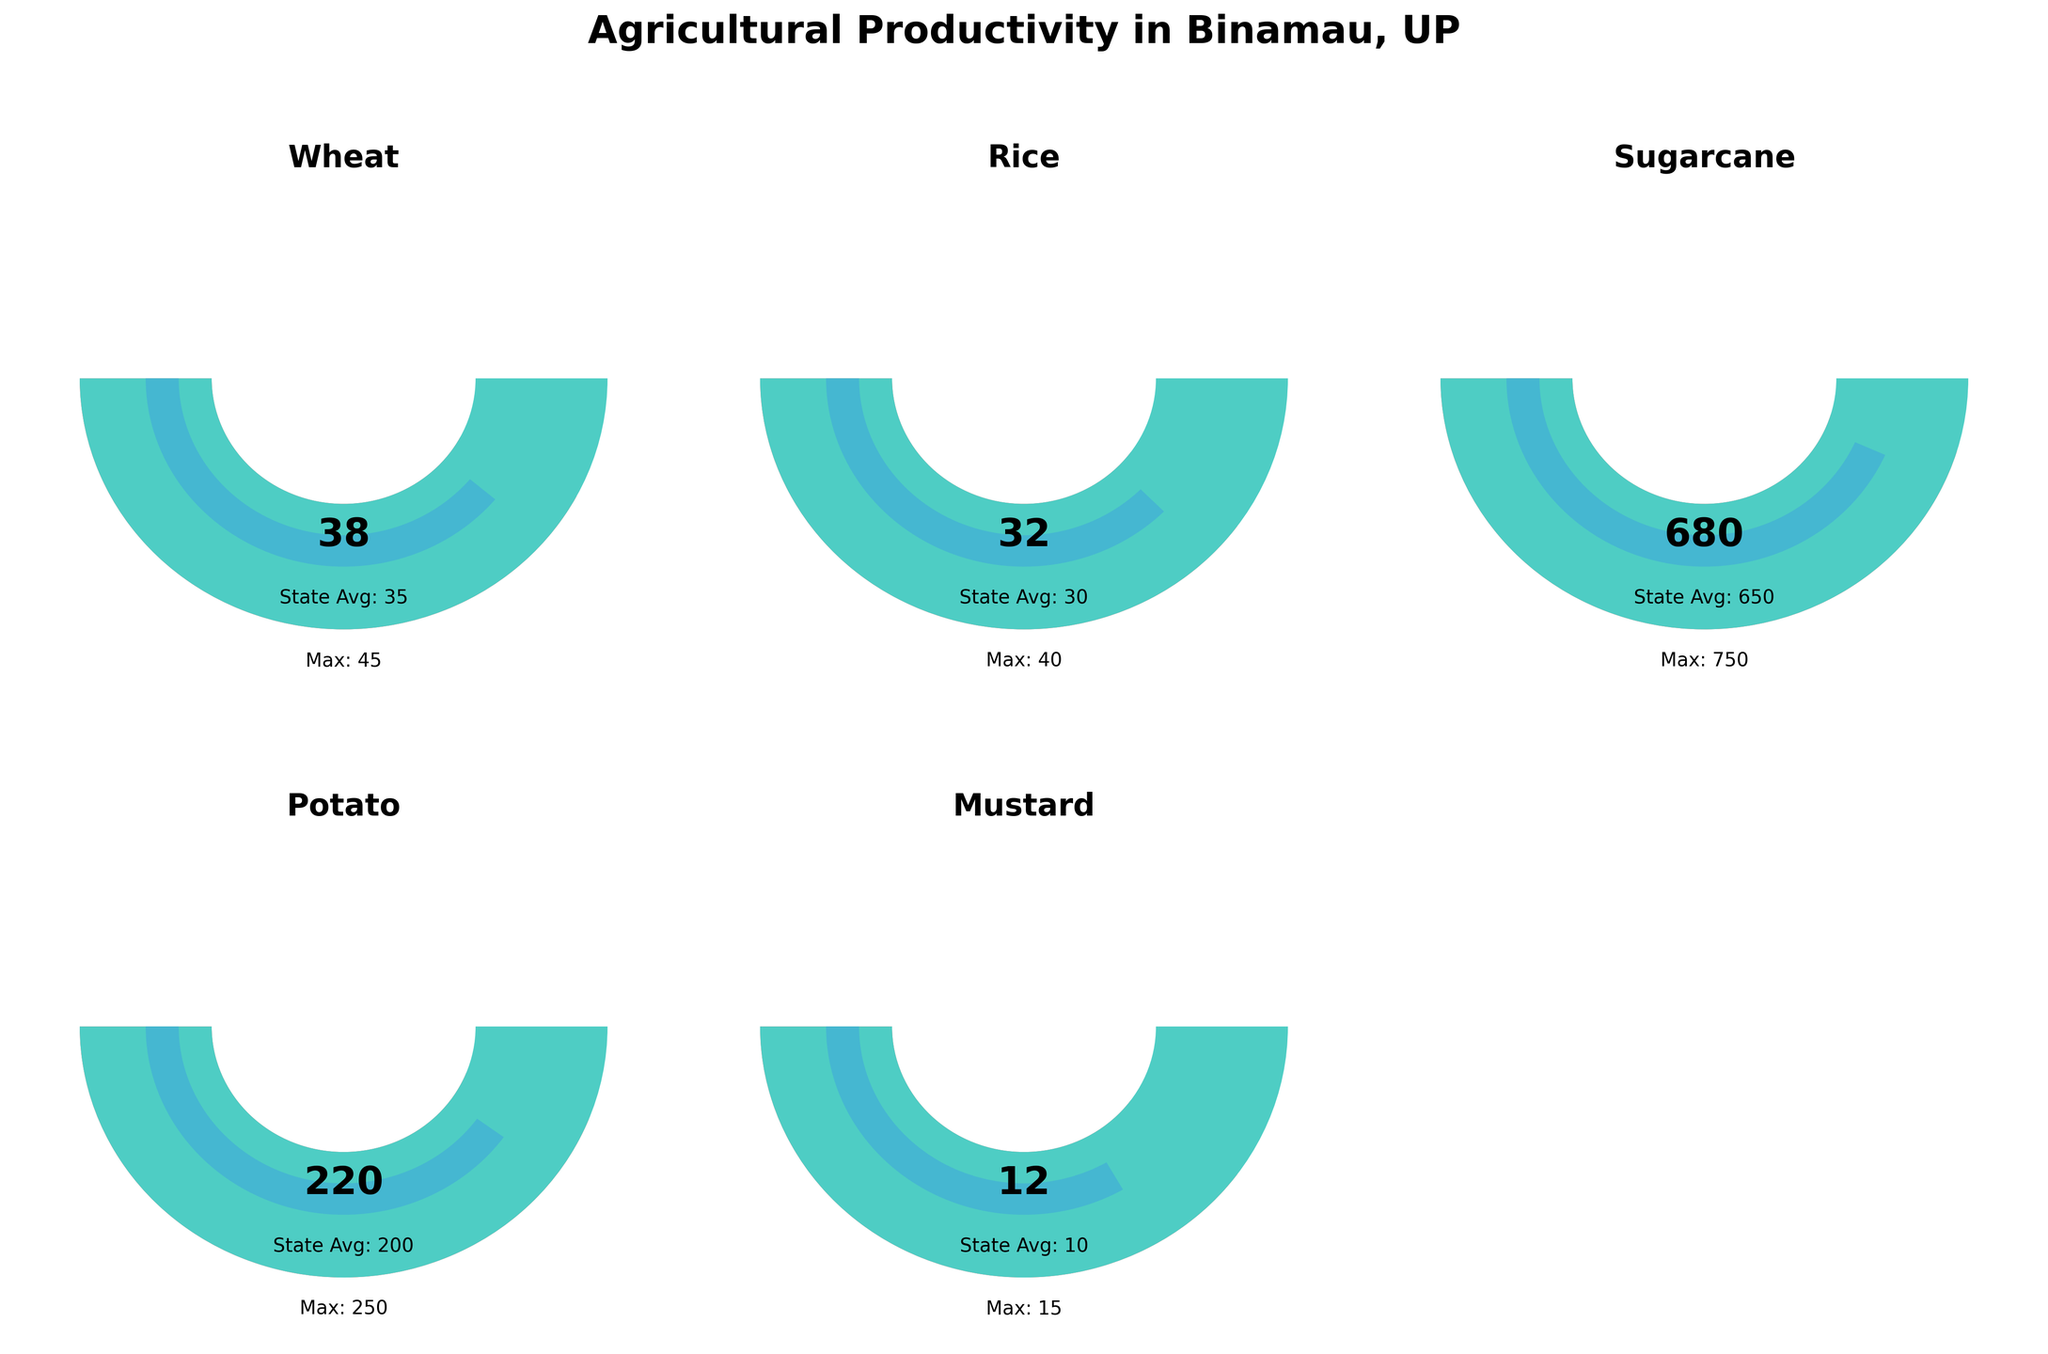How many crops are displayed in the figure? The figure displays gauge charts for five different crops.
Answer: Five What is the title of the figure? The title of the figure is "Agricultural Productivity in Binamau, UP."
Answer: Agricultural Productivity in Binamau, UP Which crop has the highest village productivity value? Look at each gauge chart and read the 'village productivity' values. Sugarcane has the highest value of 680.
Answer: Sugarcane How much higher is the village productivity of wheat compared to the state average? The village productivity of wheat is 38, and the state average is 35. Subtract the state average from the village productivity: 38 - 35 = 3.
Answer: 3 Which crop has productivity closest to its state average? Look at the 'village productivity' and 'state average' values for each crop. Mustard has a village productivity of 12 and a state average of 10, which are the closest compared to other crops.
Answer: Mustard Are there any crops where the state average productivity is higher than the village productivity? Compare 'village productivity' and 'state average' for all crops. None of the crops have a state average higher than village productivity.
Answer: No What is the maximum productivity value for potato? Refer to the value labeled as 'Max' on the potato gauge chart. It is 250.
Answer: 250 How does the village productivity of rice compare to the maximum productivity value of rice? The village productivity of rice is 32, and the maximum productivity value is 40. You can see that 32 is less than 40.
Answer: Less than 40 Which crop has the smallest difference between village productivity and maximum productivity? Calculate the difference between 'village productivity' and 'max productivity' for each crop. Mustard has the smallest difference, with 12 (village productivity) - 15 (max productivity) = 3.
Answer: Mustard What color is used to represent the state average on each gauge chart? The color used to represent the state average on each gauge chart is yellow.
Answer: Yellow 